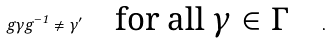<formula> <loc_0><loc_0><loc_500><loc_500>g \gamma g ^ { - 1 } \neq \gamma ^ { \prime } \quad \text {for all $\gamma \in \Gamma$} \quad .</formula> 